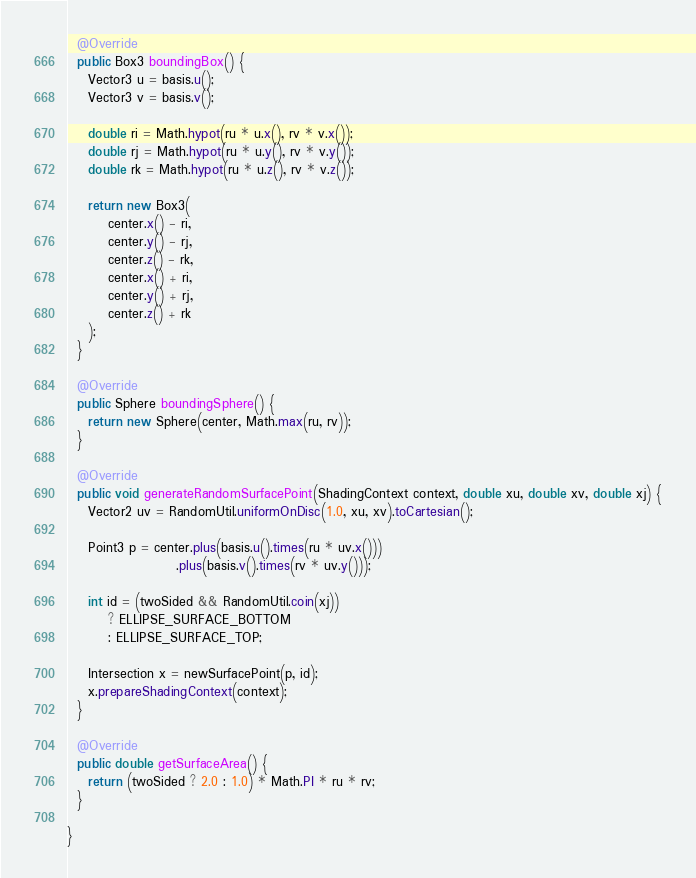Convert code to text. <code><loc_0><loc_0><loc_500><loc_500><_Java_>  @Override
  public Box3 boundingBox() {
    Vector3 u = basis.u();
    Vector3 v = basis.v();

    double ri = Math.hypot(ru * u.x(), rv * v.x());
    double rj = Math.hypot(ru * u.y(), rv * v.y());
    double rk = Math.hypot(ru * u.z(), rv * v.z());

    return new Box3(
        center.x() - ri,
        center.y() - rj,
        center.z() - rk,
        center.x() + ri,
        center.y() + rj,
        center.z() + rk
    );
  }

  @Override
  public Sphere boundingSphere() {
    return new Sphere(center, Math.max(ru, rv));
  }

  @Override
  public void generateRandomSurfacePoint(ShadingContext context, double xu, double xv, double xj) {
    Vector2 uv = RandomUtil.uniformOnDisc(1.0, xu, xv).toCartesian();

    Point3 p = center.plus(basis.u().times(ru * uv.x()))
                     .plus(basis.v().times(rv * uv.y()));

    int id = (twoSided && RandomUtil.coin(xj))
        ? ELLIPSE_SURFACE_BOTTOM
        : ELLIPSE_SURFACE_TOP;

    Intersection x = newSurfacePoint(p, id);
    x.prepareShadingContext(context);
  }

  @Override
  public double getSurfaceArea() {
    return (twoSided ? 2.0 : 1.0) * Math.PI * ru * rv;
  }

}
</code> 